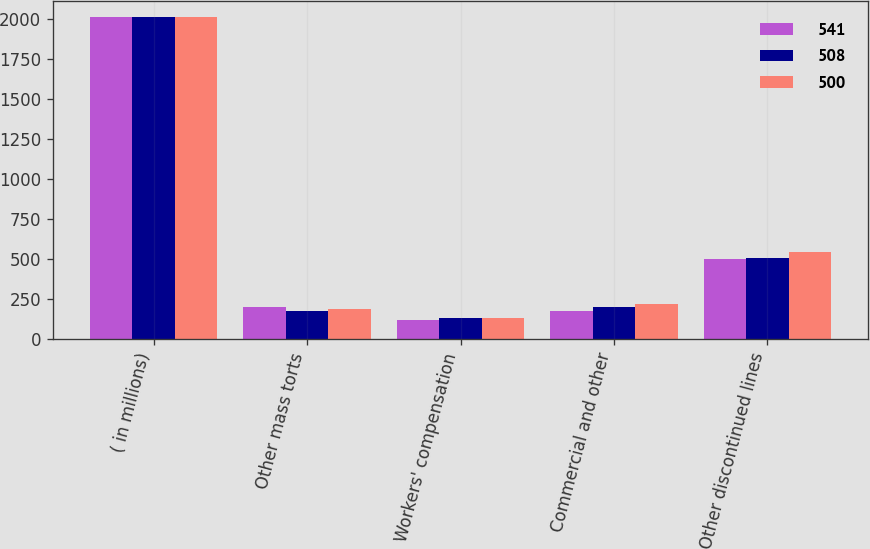Convert chart. <chart><loc_0><loc_0><loc_500><loc_500><stacked_bar_chart><ecel><fcel>( in millions)<fcel>Other mass torts<fcel>Workers' compensation<fcel>Commercial and other<fcel>Other discontinued lines<nl><fcel>541<fcel>2009<fcel>201<fcel>122<fcel>177<fcel>500<nl><fcel>508<fcel>2008<fcel>177<fcel>130<fcel>201<fcel>508<nl><fcel>500<fcel>2007<fcel>189<fcel>133<fcel>219<fcel>541<nl></chart> 